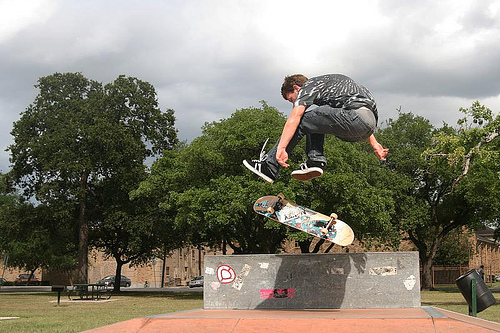<image>
Can you confirm if the park bench is to the left of the boy? Yes. From this viewpoint, the park bench is positioned to the left side relative to the boy. Where is the man in relation to the sky? Is it next to the sky? No. The man is not positioned next to the sky. They are located in different areas of the scene. 